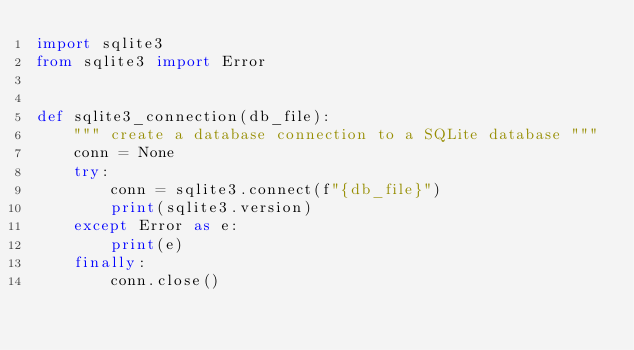<code> <loc_0><loc_0><loc_500><loc_500><_Python_>import sqlite3
from sqlite3 import Error


def sqlite3_connection(db_file):
    """ create a database connection to a SQLite database """
    conn = None
    try:
        conn = sqlite3.connect(f"{db_file}")
        print(sqlite3.version)
    except Error as e:
        print(e)
    finally:
        conn.close()
</code> 